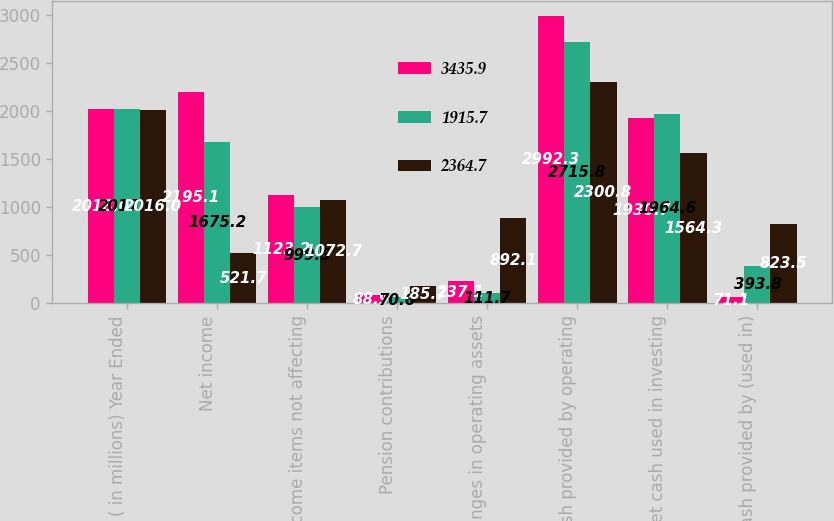Convert chart to OTSL. <chart><loc_0><loc_0><loc_500><loc_500><stacked_bar_chart><ecel><fcel>( in millions) Year Ended<fcel>Net income<fcel>Net income items not affecting<fcel>Pension contributions<fcel>Changes in operating assets<fcel>Net cash provided by operating<fcel>Net cash used in investing<fcel>Net cash provided by (used in)<nl><fcel>3435.9<fcel>2018<fcel>2195.1<fcel>1123.2<fcel>88.9<fcel>237.1<fcel>2992.3<fcel>1930.7<fcel>71.1<nl><fcel>1915.7<fcel>2017<fcel>1675.2<fcel>999.5<fcel>70.6<fcel>111.7<fcel>2715.8<fcel>1964.6<fcel>393.8<nl><fcel>2364.7<fcel>2016<fcel>521.7<fcel>1072.7<fcel>185.7<fcel>892.1<fcel>2300.8<fcel>1564.3<fcel>823.5<nl></chart> 